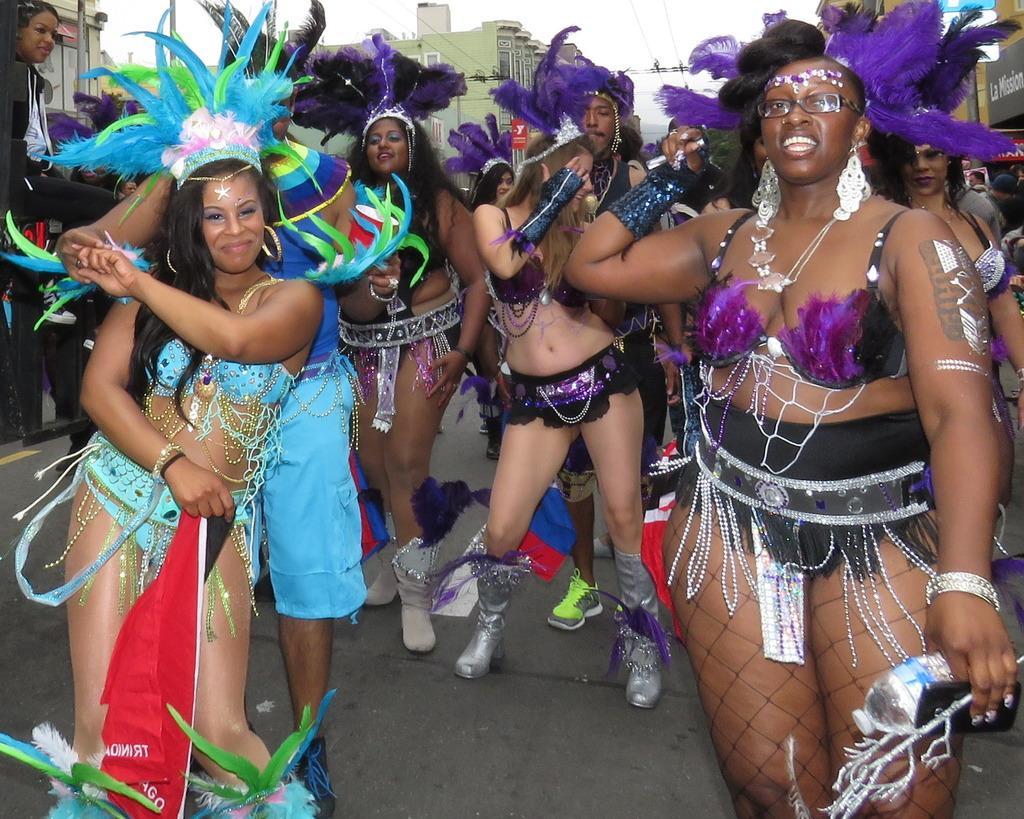How would you summarize this image in a sentence or two? In this picture there is a woman who is wearing purple and black dress. And she is holding water bottle, beside we can see many peoples were dancing. On the left we can see another woman who is wearing blue dress and holding a flag. In the background we can see the buildings. At the top there is a sky. 